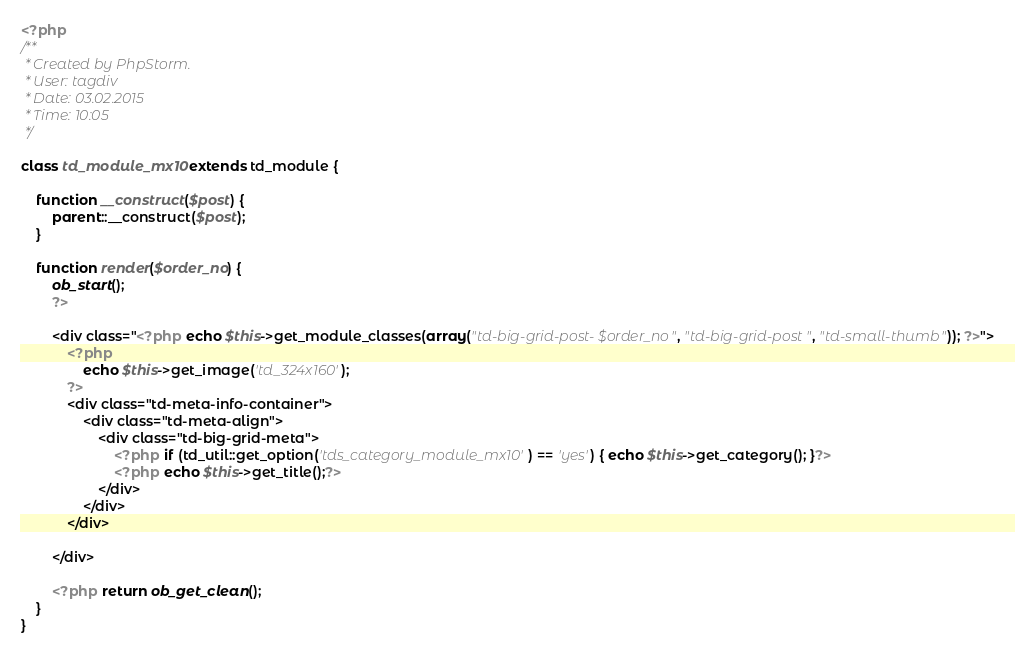<code> <loc_0><loc_0><loc_500><loc_500><_PHP_><?php
/**
 * Created by PhpStorm.
 * User: tagdiv
 * Date: 03.02.2015
 * Time: 10:05
 */

class td_module_mx10 extends td_module {

    function __construct($post) {
        parent::__construct($post);
    }

    function render($order_no) {
        ob_start();
        ?>

        <div class="<?php echo $this->get_module_classes(array("td-big-grid-post-$order_no", "td-big-grid-post", "td-small-thumb")); ?>">
            <?php
                echo $this->get_image('td_324x160');
            ?>
            <div class="td-meta-info-container">
                <div class="td-meta-align">
                    <div class="td-big-grid-meta">
                        <?php if (td_util::get_option('tds_category_module_mx10') == 'yes') { echo $this->get_category(); }?>
                        <?php echo $this->get_title();?>
                    </div>
                </div>
            </div>

        </div>

        <?php return ob_get_clean();
    }
}</code> 